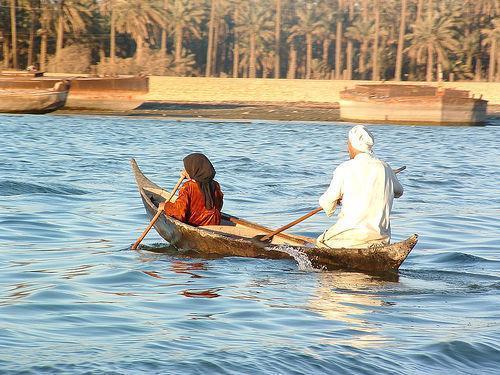How many people are in the boat?
Give a very brief answer. 2. How many people are in the photo?
Give a very brief answer. 2. 